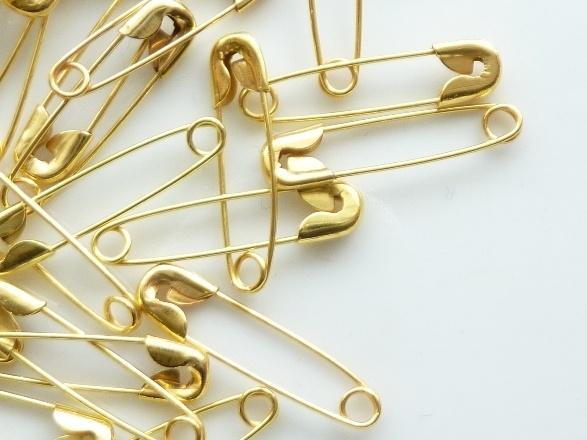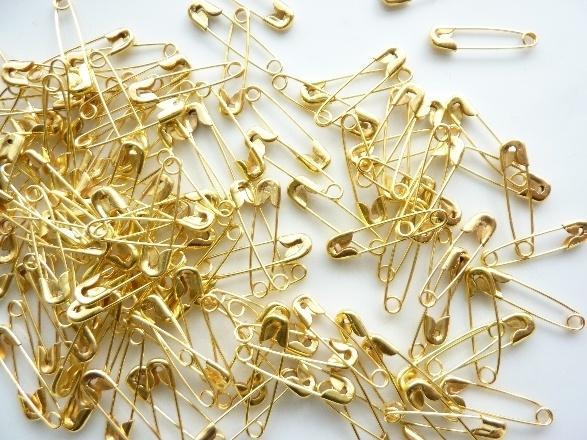The first image is the image on the left, the second image is the image on the right. Examine the images to the left and right. Is the description "Both images contain safety pins." accurate? Answer yes or no. Yes. 